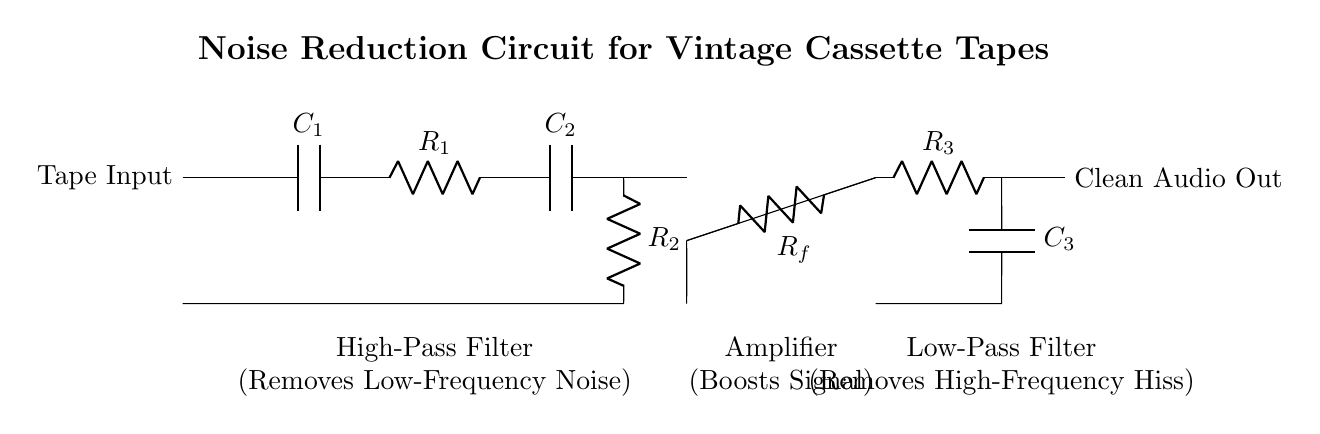What is the function of C1? C1 is a capacitor that forms part of the high-pass filter, which allows high frequencies to pass while blocking low frequencies.
Answer: High-pass filter component What does the amplifier stage do? The amplifier stage boosts the audio signal to improve clarity and volume by increasing its amplitude before further processing.
Answer: Boosts Signal Which component is responsible for removing high-frequency noise? The low-pass filter, consisting of R3 and C3, is responsible for removing high-frequency hiss from the audio signal.
Answer: Low-pass filter How many resistors are in the circuit? There are three resistors present in the circuit diagram, labeled R1, R2, and R3.
Answer: Three What type of filter is implemented after the amplifying stage? A low-pass filter is implemented after the amplifying stage, which further cleans the audio signal by filtering out high-frequency noise.
Answer: Low-pass filter What is the input signal in the circuit? The input signal to the circuit is from the tape, which is labeled as Tape Input, representing the audio signal from the cassette tape.
Answer: Tape Input Which section of the circuit is indicated to remove low-frequency noise? The high-pass filter section, which includes C2 and R2 components, is indicated to remove low-frequency noise from the audio signal.
Answer: High-pass filter 